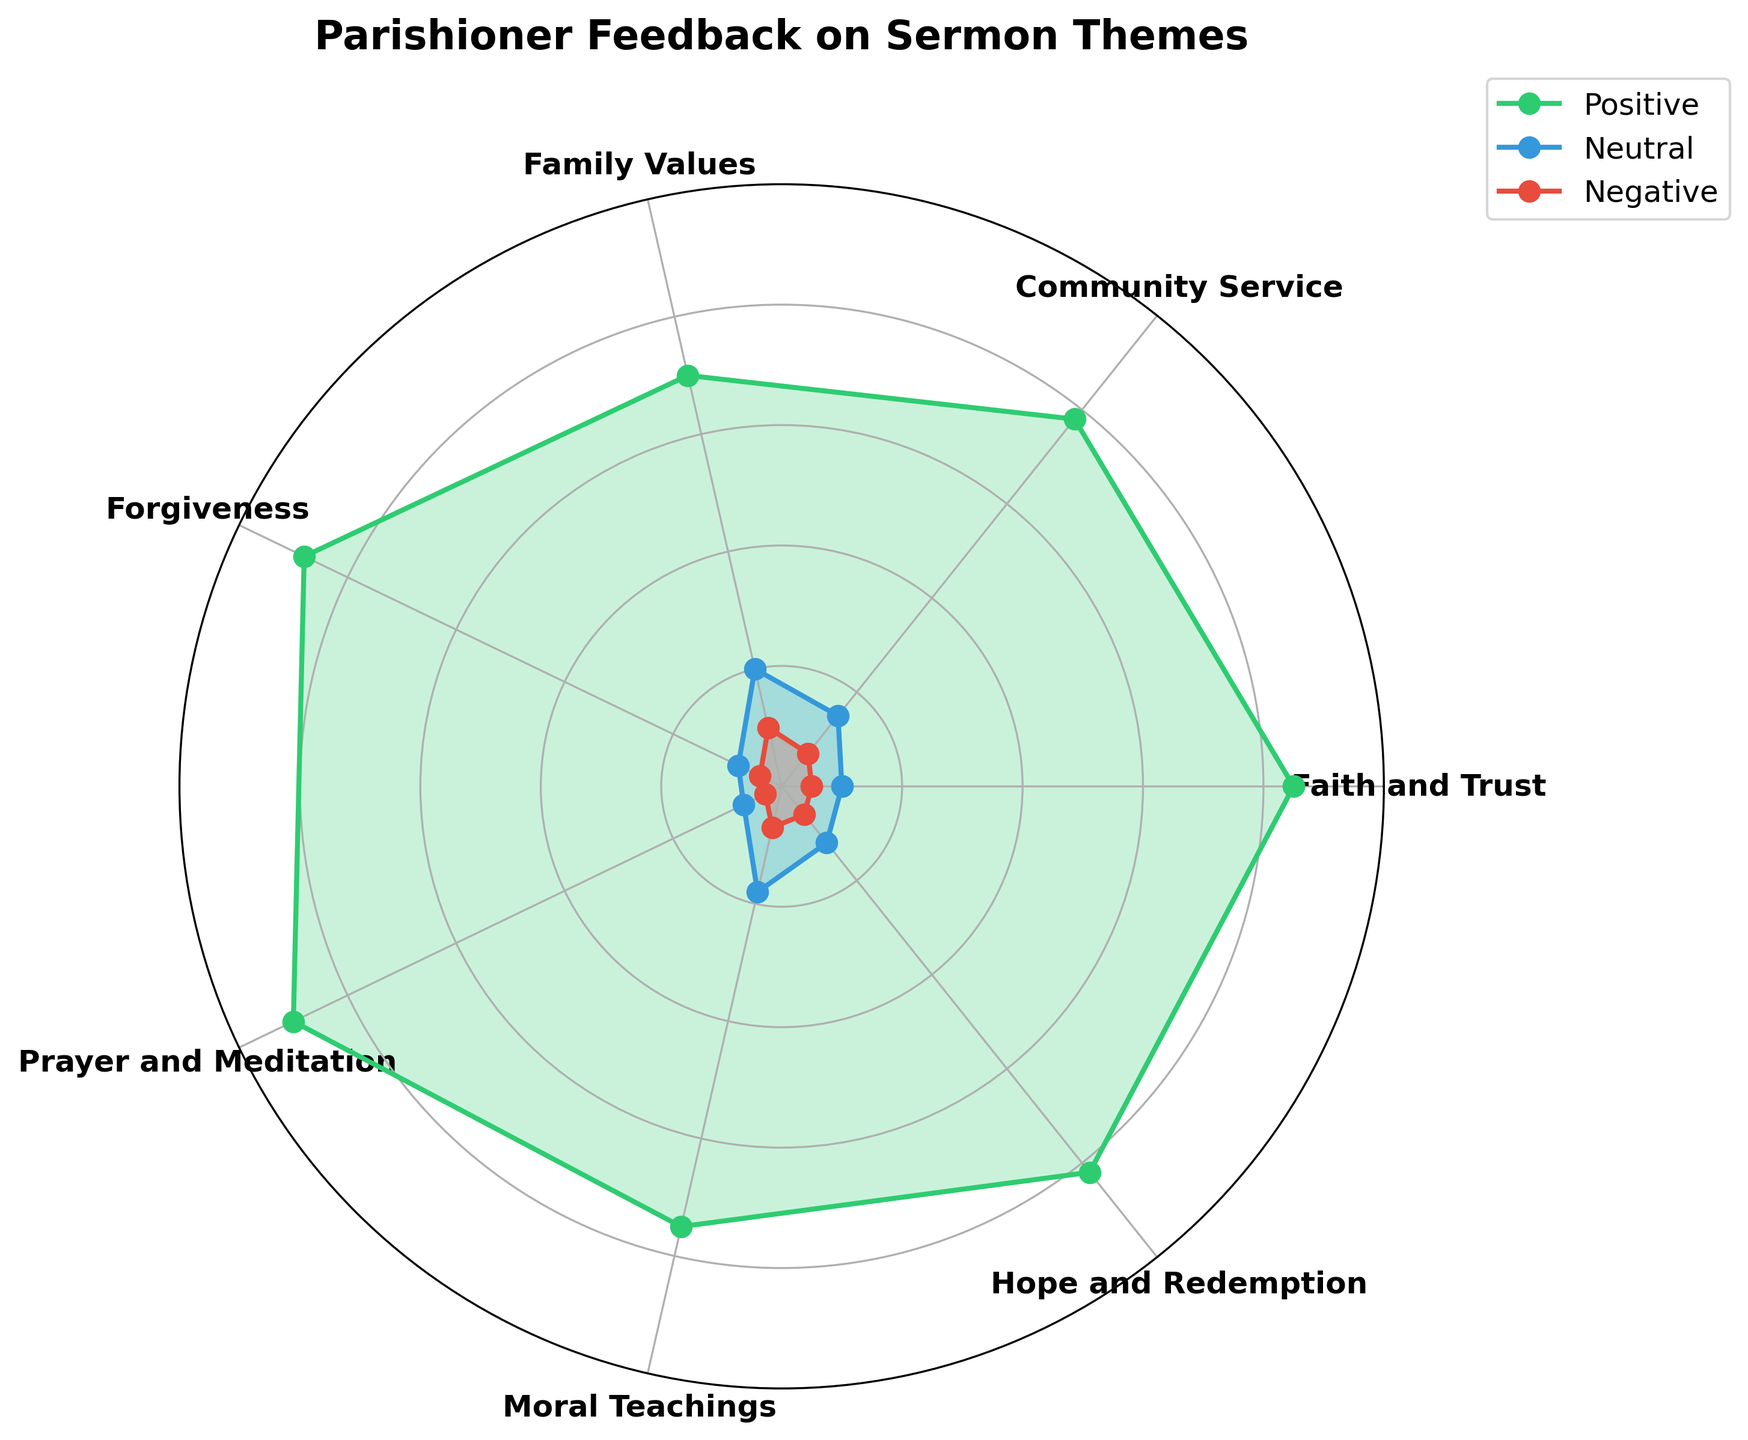Which sermon theme received the highest positive sentiment? By looking at the radar chart, we can see that "Prayer and Meditation" reaches the outermost point in the positive sentiment region, indicating the highest positive sentiment.
Answer: Prayer and Meditation Which sermon theme has the most balanced distribution of sentiments? By observing the chart, "Moral Teachings" seems to have relatively balanced scores in positive, neutral, and negative sentiments compared to other themes.
Answer: Moral Teachings How many sermon themes have a negative sentiment score above 5%? By examining the negative sentiment data, "Community Service," "Family Values," and "Hope and Redemption" have scores above 5%. Therefore, there are three themes.
Answer: 3 Which sermon themes have a positive sentiment score below 80%? By looking at the figure, we see that "Community Service," "Family Values," and "Moral Teachings" have positive sentiment scores below 80%.
Answer: Community Service, Family Values, Moral Teachings What's the difference in positive sentiment between "Faith and Trust" and "Family Values"? The positive sentiment for "Faith and Trust" is 85, and for "Family Values" it is 70. The difference is 85 - 70 = 15.
Answer: 15 Which sentiment category shows the largest variation between the themes? By comparing the spread of lines in positive, neutral, and negative regions, the neutral sentiment shows the largest variation, extending from 7 to 20.
Answer: Neutral sentiment Is there any sermon theme where neutral sentiment exceeds 19%? By looking at the radar chart, "Family Values" is the only theme where neutral sentiment is at 20%, which exceeds 19%.
Answer: Family Values What is the average negative sentiment score across all themes? Summing the negative sentiment scores (5 + 7 + 10 + 4 + 3 + 7 + 6) gives 42. There are 7 themes, so the average is 42/7 = 6.
Answer: 6 Which two themes have the closest positive sentiment scores? By examining the positive sentiment areas on the chart, "Hope and Redemption" (82) and "Faith and Trust" (85) have close positive sentiment scores with a difference of 3.
Answer: Hope and Redemption and Faith and Trust What is the total positive sentiment across all themes? Adding the positive sentiment scores: 85 + 78 + 70 + 88 + 90 + 75 + 82 = 568.
Answer: 568 